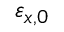<formula> <loc_0><loc_0><loc_500><loc_500>\varepsilon _ { x , 0 }</formula> 